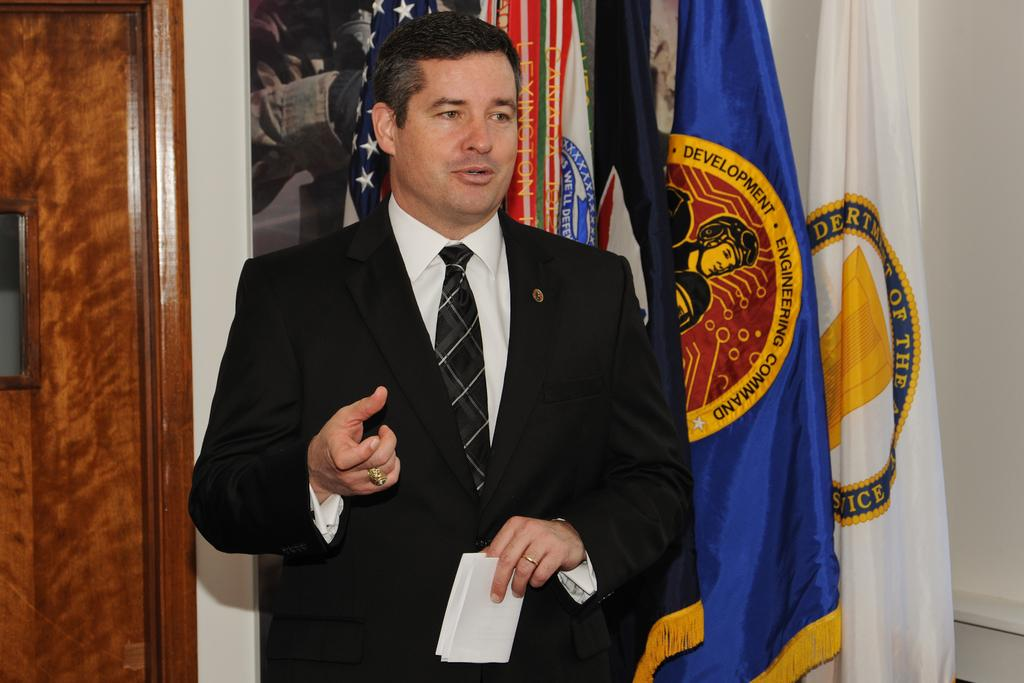Provide a one-sentence caption for the provided image. A man stands in front of several flags, one reading Development Engineering Command. 